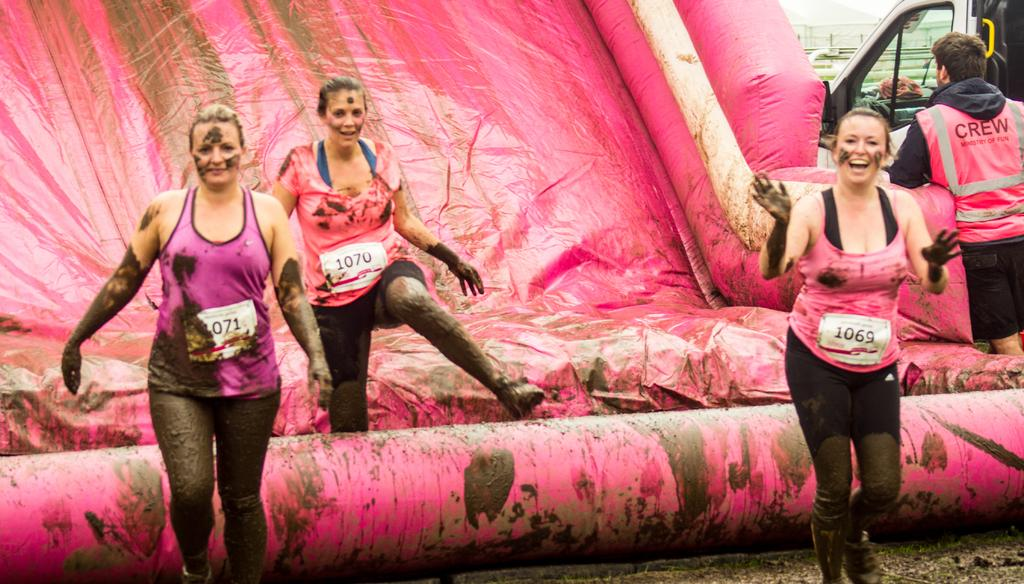How many people are in the image? There are women and a man standing in the image, making a total of three people. What are the women wearing? The women are wearing tank tops. What can be seen in the background of the image? There is a vehicle and a pink color object in the background of the image. What type of table is visible in the image? There is no table present in the image. Can you describe the facial expressions of the people in the image? The provided facts do not mention any facial expressions of the people in the image. 